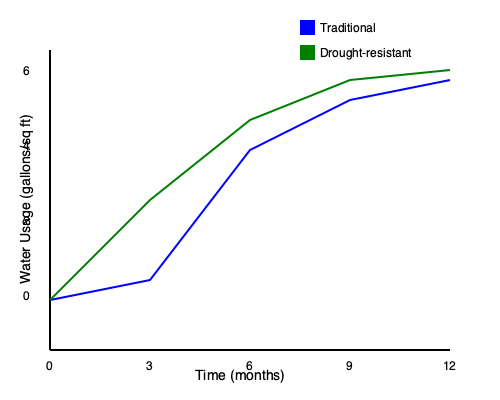You're planning to revamp your backyard, because let's face it, your current "drought-resistant" rock garden is about as exciting as watching paint dry. Based on the water usage data shown in the graph, calculate the total water savings (in gallons per square foot) over a year if you switch from a traditional landscaping design to a drought-resistant one. Oh, and while you're at it, maybe suggest a succulent or two that won't make your yard look like a Mars colony? Alright, let's break this down step-by-step, because who doesn't love a good DIY water-saving project?

1) First, we need to calculate the area under each curve to find the total water usage for both landscaping types over the year. We can approximate this using the trapezoidal rule.

2) For the traditional landscaping (blue line):
   Area ≈ $\frac{1}{2}(6+5.4+3+2+1.6)(12) = 54$ gallons/sq ft

3) For the drought-resistant landscaping (green line):
   Area ≈ $\frac{1}{2}(6+4+2.4+1.6+1.4)(12) = 46.2$ gallons/sq ft

4) Now, let's calculate the difference:
   Water savings = Traditional usage - Drought-resistant usage
                 = $54 - 46.2 = 7.8$ gallons/sq ft

5) As for plant suggestions, how about a nice Echeveria or Sedum? They're like the avocado toast of the succulent world - trendy, low-maintenance, and they won't drain your water budget faster than a leaky faucet.
Answer: 7.8 gallons/sq ft 